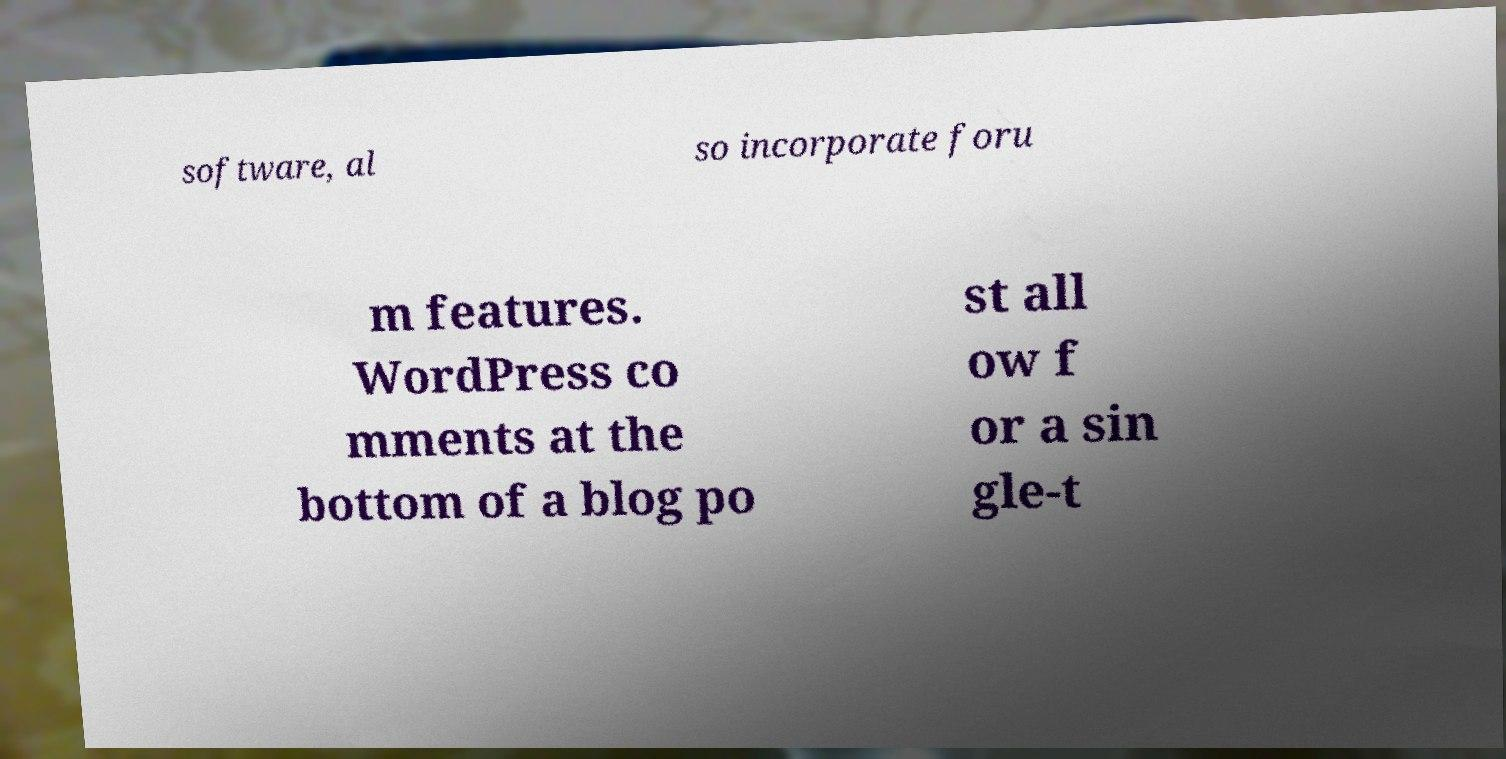Could you assist in decoding the text presented in this image and type it out clearly? software, al so incorporate foru m features. WordPress co mments at the bottom of a blog po st all ow f or a sin gle-t 